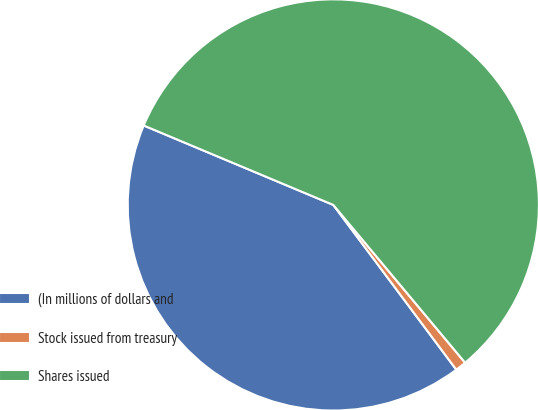<chart> <loc_0><loc_0><loc_500><loc_500><pie_chart><fcel>(In millions of dollars and<fcel>Stock issued from treasury<fcel>Shares issued<nl><fcel>41.52%<fcel>0.87%<fcel>57.61%<nl></chart> 